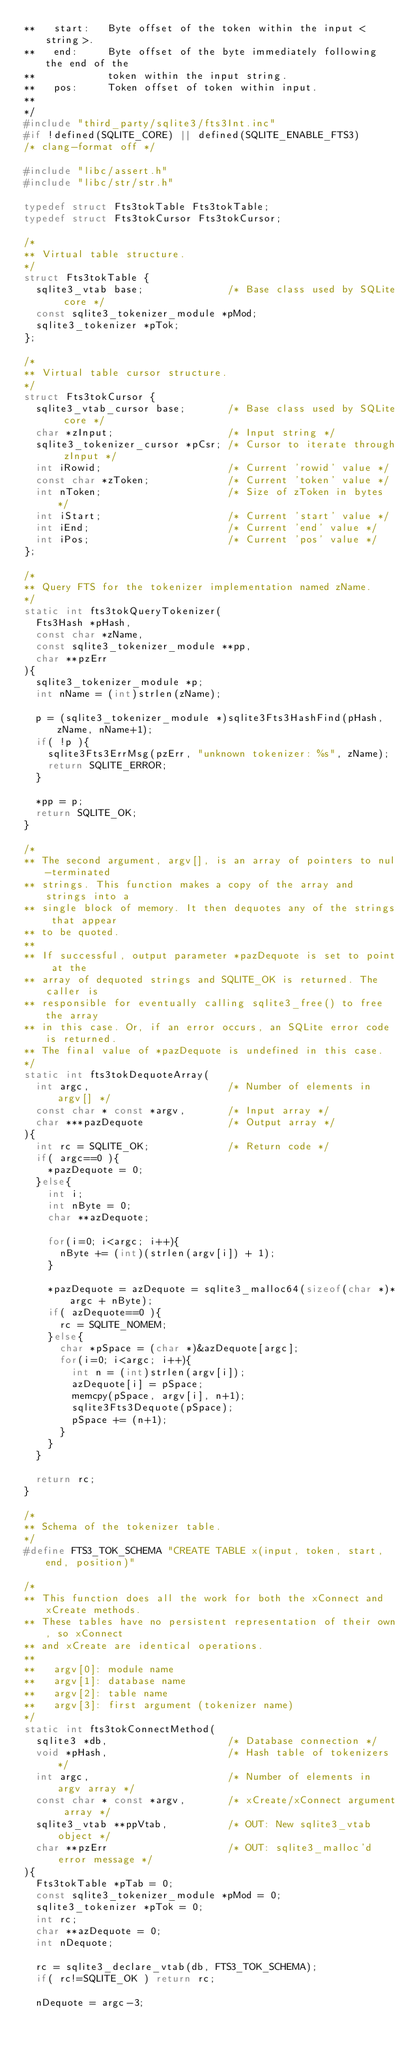<code> <loc_0><loc_0><loc_500><loc_500><_C_>**   start:   Byte offset of the token within the input <string>.
**   end:     Byte offset of the byte immediately following the end of the
**            token within the input string.
**   pos:     Token offset of token within input.
**
*/
#include "third_party/sqlite3/fts3Int.inc"
#if !defined(SQLITE_CORE) || defined(SQLITE_ENABLE_FTS3)
/* clang-format off */

#include "libc/assert.h"
#include "libc/str/str.h"

typedef struct Fts3tokTable Fts3tokTable;
typedef struct Fts3tokCursor Fts3tokCursor;

/*
** Virtual table structure.
*/
struct Fts3tokTable {
  sqlite3_vtab base;              /* Base class used by SQLite core */
  const sqlite3_tokenizer_module *pMod;
  sqlite3_tokenizer *pTok;
};

/*
** Virtual table cursor structure.
*/
struct Fts3tokCursor {
  sqlite3_vtab_cursor base;       /* Base class used by SQLite core */
  char *zInput;                   /* Input string */
  sqlite3_tokenizer_cursor *pCsr; /* Cursor to iterate through zInput */
  int iRowid;                     /* Current 'rowid' value */
  const char *zToken;             /* Current 'token' value */
  int nToken;                     /* Size of zToken in bytes */
  int iStart;                     /* Current 'start' value */
  int iEnd;                       /* Current 'end' value */
  int iPos;                       /* Current 'pos' value */
};

/*
** Query FTS for the tokenizer implementation named zName.
*/
static int fts3tokQueryTokenizer(
  Fts3Hash *pHash,
  const char *zName,
  const sqlite3_tokenizer_module **pp,
  char **pzErr
){
  sqlite3_tokenizer_module *p;
  int nName = (int)strlen(zName);

  p = (sqlite3_tokenizer_module *)sqlite3Fts3HashFind(pHash, zName, nName+1);
  if( !p ){
    sqlite3Fts3ErrMsg(pzErr, "unknown tokenizer: %s", zName);
    return SQLITE_ERROR;
  }

  *pp = p;
  return SQLITE_OK;
}

/*
** The second argument, argv[], is an array of pointers to nul-terminated
** strings. This function makes a copy of the array and strings into a 
** single block of memory. It then dequotes any of the strings that appear
** to be quoted.
**
** If successful, output parameter *pazDequote is set to point at the
** array of dequoted strings and SQLITE_OK is returned. The caller is
** responsible for eventually calling sqlite3_free() to free the array
** in this case. Or, if an error occurs, an SQLite error code is returned.
** The final value of *pazDequote is undefined in this case.
*/
static int fts3tokDequoteArray(
  int argc,                       /* Number of elements in argv[] */
  const char * const *argv,       /* Input array */
  char ***pazDequote              /* Output array */
){
  int rc = SQLITE_OK;             /* Return code */
  if( argc==0 ){
    *pazDequote = 0;
  }else{
    int i;
    int nByte = 0;
    char **azDequote;

    for(i=0; i<argc; i++){
      nByte += (int)(strlen(argv[i]) + 1);
    }

    *pazDequote = azDequote = sqlite3_malloc64(sizeof(char *)*argc + nByte);
    if( azDequote==0 ){
      rc = SQLITE_NOMEM;
    }else{
      char *pSpace = (char *)&azDequote[argc];
      for(i=0; i<argc; i++){
        int n = (int)strlen(argv[i]);
        azDequote[i] = pSpace;
        memcpy(pSpace, argv[i], n+1);
        sqlite3Fts3Dequote(pSpace);
        pSpace += (n+1);
      }
    }
  }

  return rc;
}

/*
** Schema of the tokenizer table.
*/
#define FTS3_TOK_SCHEMA "CREATE TABLE x(input, token, start, end, position)"

/*
** This function does all the work for both the xConnect and xCreate methods.
** These tables have no persistent representation of their own, so xConnect
** and xCreate are identical operations.
**
**   argv[0]: module name
**   argv[1]: database name 
**   argv[2]: table name
**   argv[3]: first argument (tokenizer name)
*/
static int fts3tokConnectMethod(
  sqlite3 *db,                    /* Database connection */
  void *pHash,                    /* Hash table of tokenizers */
  int argc,                       /* Number of elements in argv array */
  const char * const *argv,       /* xCreate/xConnect argument array */
  sqlite3_vtab **ppVtab,          /* OUT: New sqlite3_vtab object */
  char **pzErr                    /* OUT: sqlite3_malloc'd error message */
){
  Fts3tokTable *pTab = 0;
  const sqlite3_tokenizer_module *pMod = 0;
  sqlite3_tokenizer *pTok = 0;
  int rc;
  char **azDequote = 0;
  int nDequote;

  rc = sqlite3_declare_vtab(db, FTS3_TOK_SCHEMA);
  if( rc!=SQLITE_OK ) return rc;

  nDequote = argc-3;</code> 